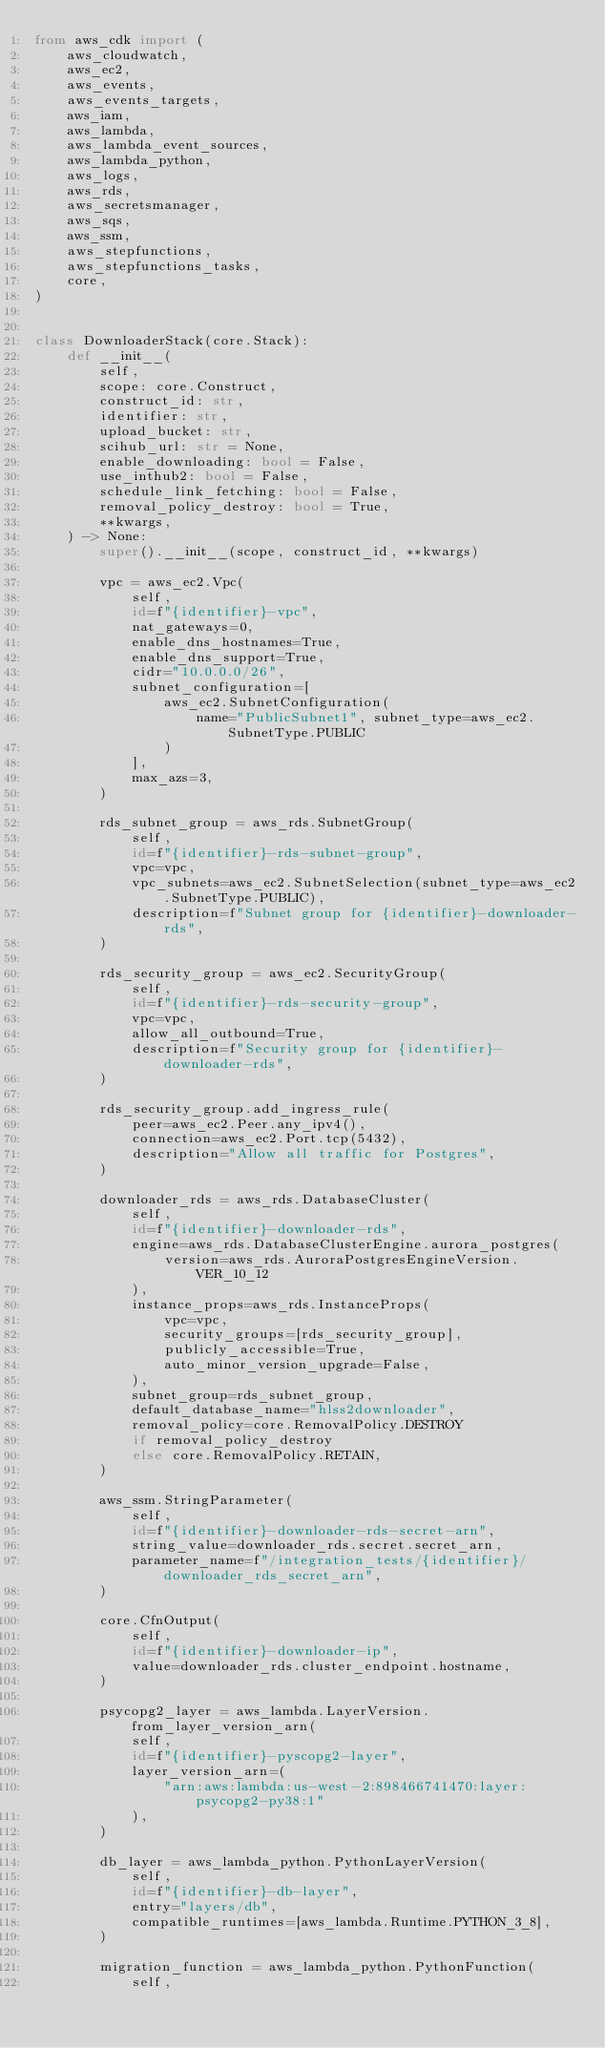Convert code to text. <code><loc_0><loc_0><loc_500><loc_500><_Python_>from aws_cdk import (
    aws_cloudwatch,
    aws_ec2,
    aws_events,
    aws_events_targets,
    aws_iam,
    aws_lambda,
    aws_lambda_event_sources,
    aws_lambda_python,
    aws_logs,
    aws_rds,
    aws_secretsmanager,
    aws_sqs,
    aws_ssm,
    aws_stepfunctions,
    aws_stepfunctions_tasks,
    core,
)


class DownloaderStack(core.Stack):
    def __init__(
        self,
        scope: core.Construct,
        construct_id: str,
        identifier: str,
        upload_bucket: str,
        scihub_url: str = None,
        enable_downloading: bool = False,
        use_inthub2: bool = False,
        schedule_link_fetching: bool = False,
        removal_policy_destroy: bool = True,
        **kwargs,
    ) -> None:
        super().__init__(scope, construct_id, **kwargs)

        vpc = aws_ec2.Vpc(
            self,
            id=f"{identifier}-vpc",
            nat_gateways=0,
            enable_dns_hostnames=True,
            enable_dns_support=True,
            cidr="10.0.0.0/26",
            subnet_configuration=[
                aws_ec2.SubnetConfiguration(
                    name="PublicSubnet1", subnet_type=aws_ec2.SubnetType.PUBLIC
                )
            ],
            max_azs=3,
        )

        rds_subnet_group = aws_rds.SubnetGroup(
            self,
            id=f"{identifier}-rds-subnet-group",
            vpc=vpc,
            vpc_subnets=aws_ec2.SubnetSelection(subnet_type=aws_ec2.SubnetType.PUBLIC),
            description=f"Subnet group for {identifier}-downloader-rds",
        )

        rds_security_group = aws_ec2.SecurityGroup(
            self,
            id=f"{identifier}-rds-security-group",
            vpc=vpc,
            allow_all_outbound=True,
            description=f"Security group for {identifier}-downloader-rds",
        )

        rds_security_group.add_ingress_rule(
            peer=aws_ec2.Peer.any_ipv4(),
            connection=aws_ec2.Port.tcp(5432),
            description="Allow all traffic for Postgres",
        )

        downloader_rds = aws_rds.DatabaseCluster(
            self,
            id=f"{identifier}-downloader-rds",
            engine=aws_rds.DatabaseClusterEngine.aurora_postgres(
                version=aws_rds.AuroraPostgresEngineVersion.VER_10_12
            ),
            instance_props=aws_rds.InstanceProps(
                vpc=vpc,
                security_groups=[rds_security_group],
                publicly_accessible=True,
                auto_minor_version_upgrade=False,
            ),
            subnet_group=rds_subnet_group,
            default_database_name="hlss2downloader",
            removal_policy=core.RemovalPolicy.DESTROY
            if removal_policy_destroy
            else core.RemovalPolicy.RETAIN,
        )

        aws_ssm.StringParameter(
            self,
            id=f"{identifier}-downloader-rds-secret-arn",
            string_value=downloader_rds.secret.secret_arn,
            parameter_name=f"/integration_tests/{identifier}/downloader_rds_secret_arn",
        )

        core.CfnOutput(
            self,
            id=f"{identifier}-downloader-ip",
            value=downloader_rds.cluster_endpoint.hostname,
        )

        psycopg2_layer = aws_lambda.LayerVersion.from_layer_version_arn(
            self,
            id=f"{identifier}-pyscopg2-layer",
            layer_version_arn=(
                "arn:aws:lambda:us-west-2:898466741470:layer:psycopg2-py38:1"
            ),
        )

        db_layer = aws_lambda_python.PythonLayerVersion(
            self,
            id=f"{identifier}-db-layer",
            entry="layers/db",
            compatible_runtimes=[aws_lambda.Runtime.PYTHON_3_8],
        )

        migration_function = aws_lambda_python.PythonFunction(
            self,</code> 